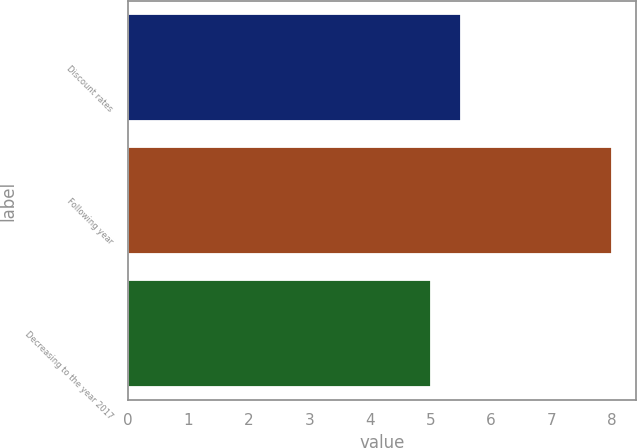Convert chart to OTSL. <chart><loc_0><loc_0><loc_500><loc_500><bar_chart><fcel>Discount rates<fcel>Following year<fcel>Decreasing to the year 2017<nl><fcel>5.5<fcel>8<fcel>5<nl></chart> 